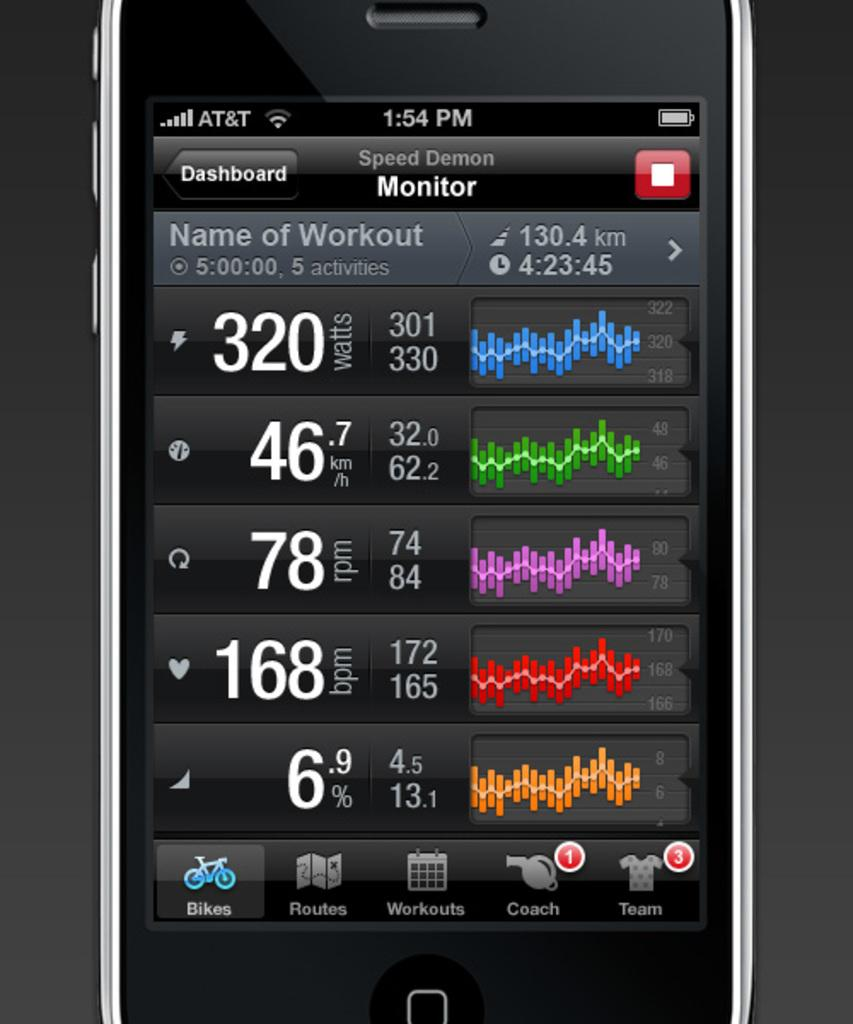<image>
Render a clear and concise summary of the photo. A phone has the Speed Demon monitor up on its screen. 